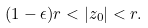Convert formula to latex. <formula><loc_0><loc_0><loc_500><loc_500>( 1 - \epsilon ) r < | z _ { 0 } | < r .</formula> 